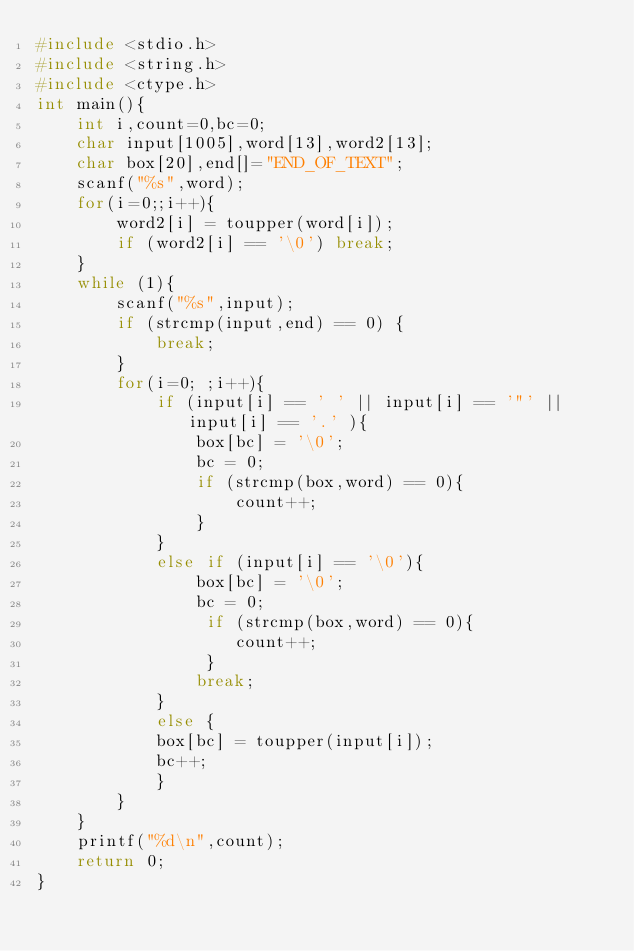<code> <loc_0><loc_0><loc_500><loc_500><_C_>#include <stdio.h>
#include <string.h>
#include <ctype.h>
int main(){
    int i,count=0,bc=0;
    char input[1005],word[13],word2[13];
    char box[20],end[]="END_OF_TEXT";
    scanf("%s",word);
    for(i=0;;i++){
        word2[i] = toupper(word[i]);
        if (word2[i] == '\0') break;
    }
    while (1){
        scanf("%s",input);
        if (strcmp(input,end) == 0) {
            break;
        }
        for(i=0; ;i++){
            if (input[i] == ' ' || input[i] == '"' || input[i] == '.' ){
                box[bc] = '\0';
                bc = 0;
                if (strcmp(box,word) == 0){
                    count++;
                }
            }
            else if (input[i] == '\0'){
                box[bc] = '\0';
                bc = 0;
                 if (strcmp(box,word) == 0){
                    count++;
                 }
                break;
            }
            else {
            box[bc] = toupper(input[i]);
            bc++;
            }
        }
    }
    printf("%d\n",count);
    return 0;
}</code> 